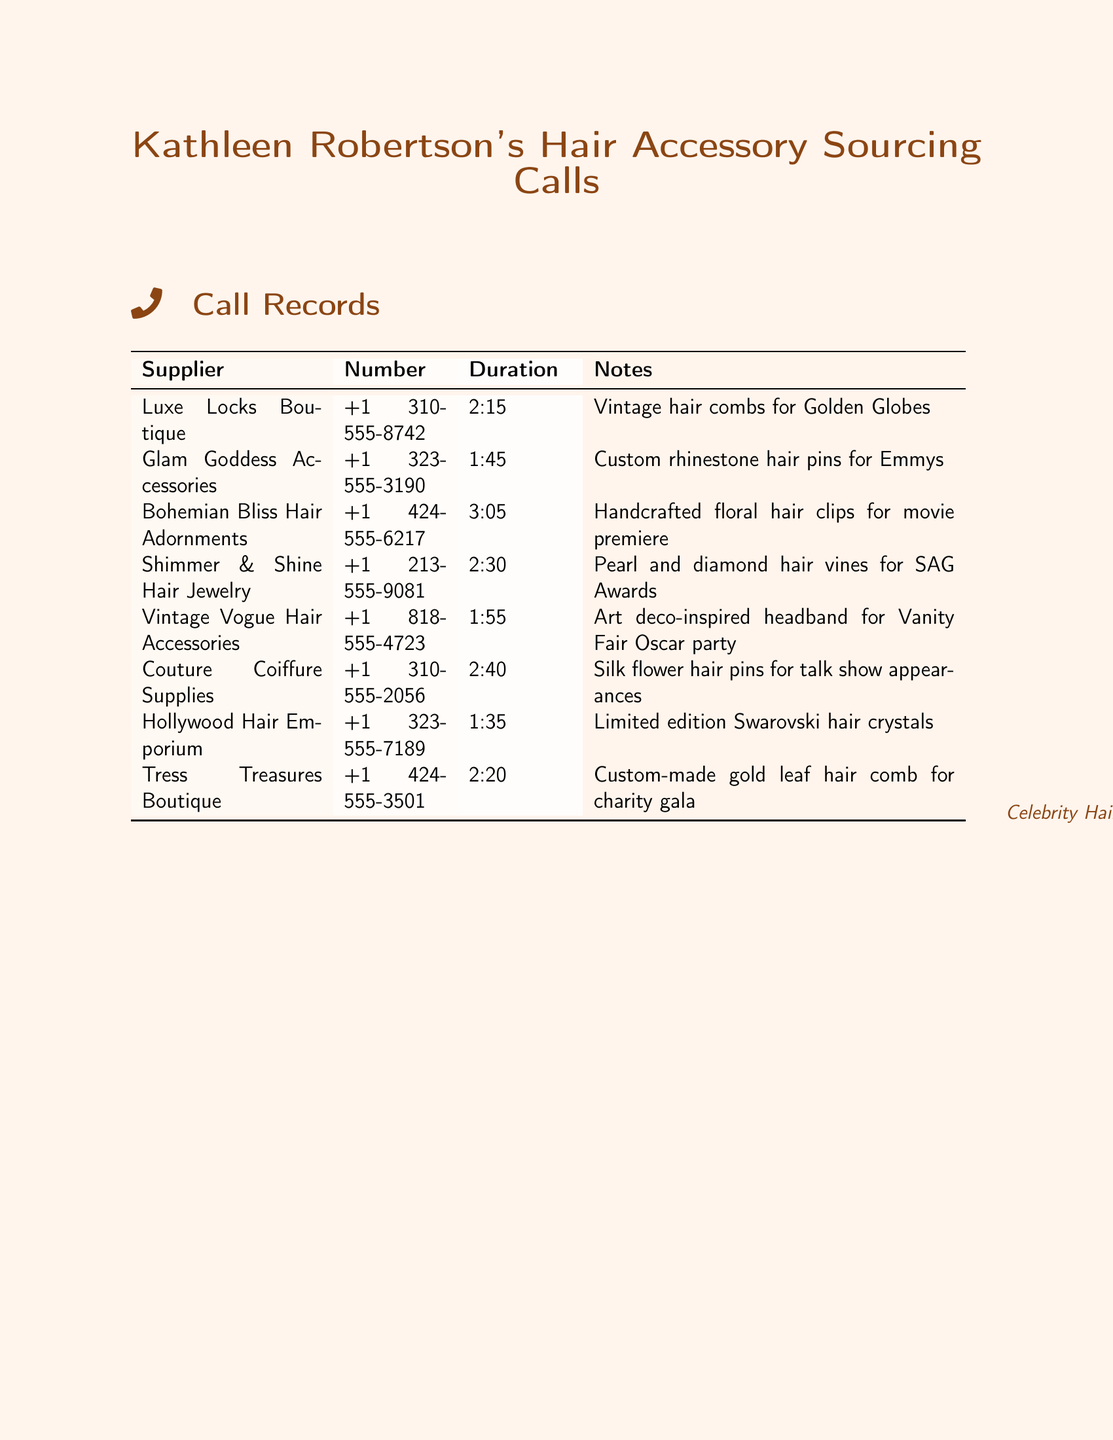What is the name of the supplier for vintage hair combs? The name of the supplier for vintage hair combs is "Luxe Locks Boutique," as noted in the document.
Answer: Luxe Locks Boutique What is the duration of the call with Glam Goddess Accessories? The document states that the duration of the call with Glam Goddess Accessories is 1 minute and 45 seconds.
Answer: 1:45 Which accessory was sourced from Bohemian Bliss Hair Adornments? The document mentions that handcrafted floral hair clips were sourced from Bohemian Bliss Hair Adornments.
Answer: Handcrafted floral hair clips What type of hair accessory was discussed in the call with Shimmer & Shine Hair Jewelry? The call with Shimmer & Shine Hair Jewelry discussed pearl and diamond hair vines for the SAG Awards.
Answer: Pearl and diamond hair vines Which boutique provided custom-made gold leaf hair comb? According to the document, Tress Treasures Boutique provided the custom-made gold leaf hair comb.
Answer: Tress Treasures Boutique How long was the call with Vintage Vogue Hair Accessories? The document indicates that the call with Vintage Vogue Hair Accessories lasted for 1 minute and 55 seconds.
Answer: 1:55 What is the phone number for Hollywood Hair Emporium? The phone number for Hollywood Hair Emporium, as shown in the document, is +1 323-555-7189.
Answer: +1 323-555-7189 Which event were custom rhinestone hair pins sourced for? The document states that the custom rhinestone hair pins were sourced for the Emmys.
Answer: Emmys 